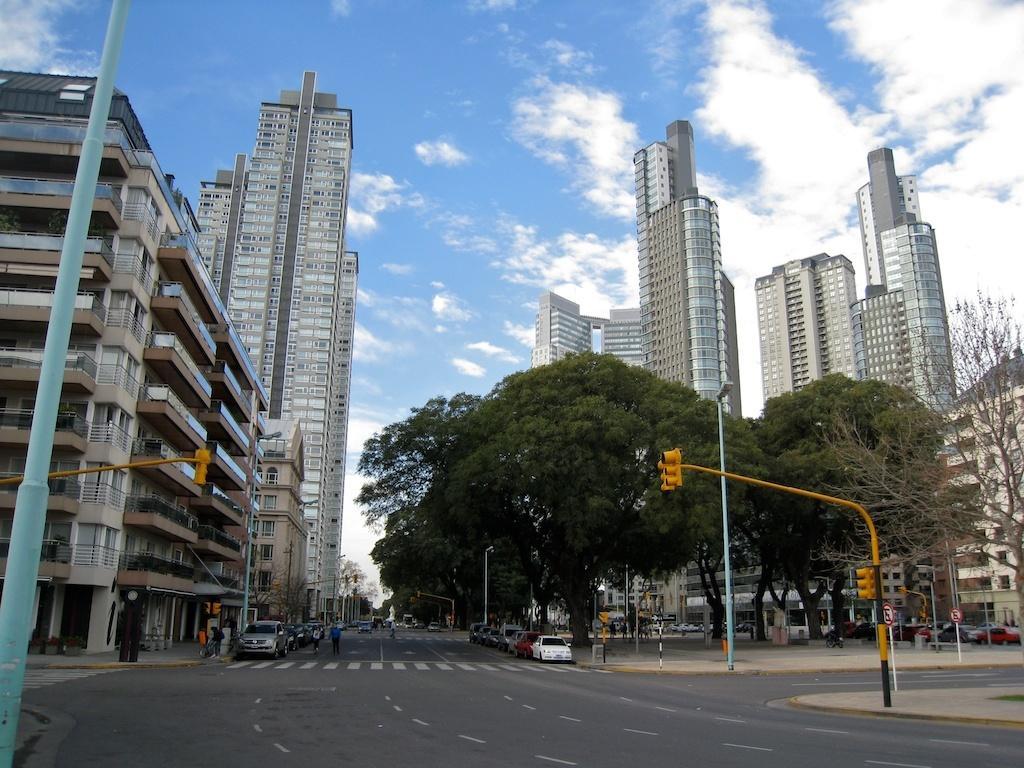Describe this image in one or two sentences. In this picture we can see vehicles on the roads. On the left and right side of the road, there are poles with traffic signals, boards and lights. On the right side of the vehicles, there are trees. On the left and right side of the image, there are buildings. At the top of the image, there is the sky. 